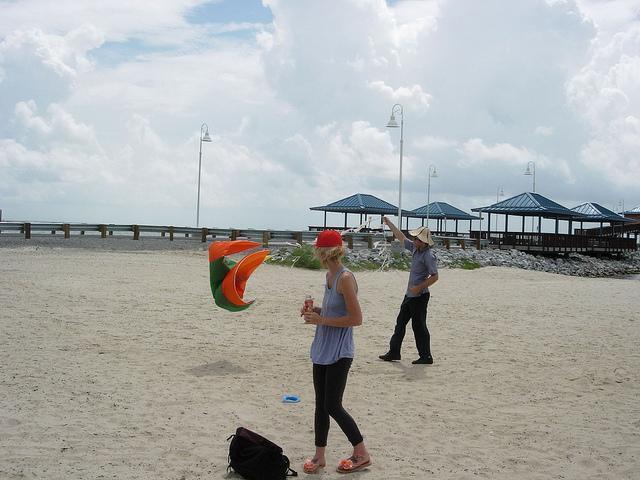How many backpacks are there?
Give a very brief answer. 1. How many people are there?
Give a very brief answer. 2. How many sinks are visible?
Give a very brief answer. 0. 